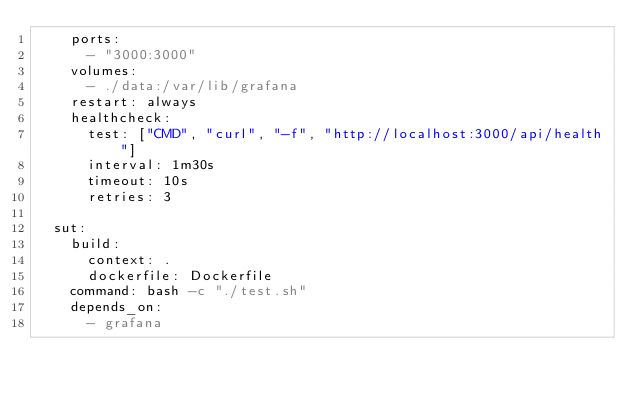<code> <loc_0><loc_0><loc_500><loc_500><_YAML_>    ports:
      - "3000:3000"
    volumes:
      - ./data:/var/lib/grafana
    restart: always
    healthcheck:
      test: ["CMD", "curl", "-f", "http://localhost:3000/api/health"]
      interval: 1m30s
      timeout: 10s
      retries: 3
          
  sut:
    build:
      context: .
      dockerfile: Dockerfile
    command: bash -c "./test.sh"
    depends_on: 
      - grafana</code> 